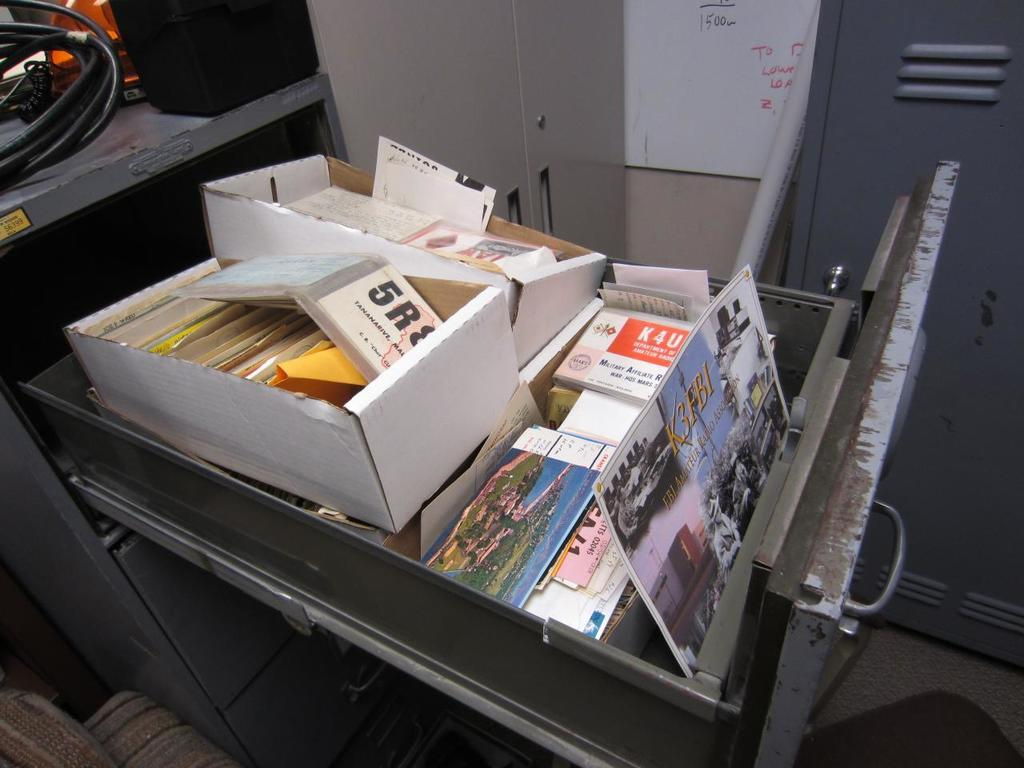<image>
Summarize the visual content of the image. a filing cabinet is full of papers including one about Amateur Radio 